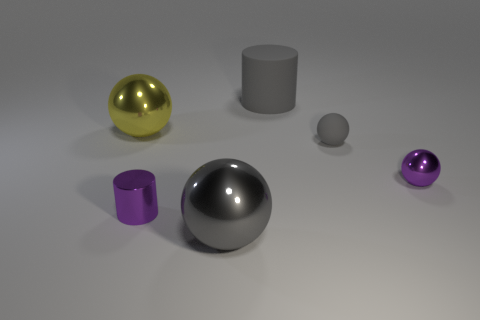Subtract all cylinders. How many objects are left? 4 Subtract 2 cylinders. How many cylinders are left? 0 Subtract all brown cylinders. Subtract all gray balls. How many cylinders are left? 2 Subtract all gray balls. How many purple cylinders are left? 1 Subtract all yellow metallic cylinders. Subtract all tiny rubber spheres. How many objects are left? 5 Add 6 rubber things. How many rubber things are left? 8 Add 5 yellow metal spheres. How many yellow metal spheres exist? 6 Add 1 yellow balls. How many objects exist? 7 Subtract all yellow spheres. How many spheres are left? 3 Subtract all yellow balls. How many balls are left? 3 